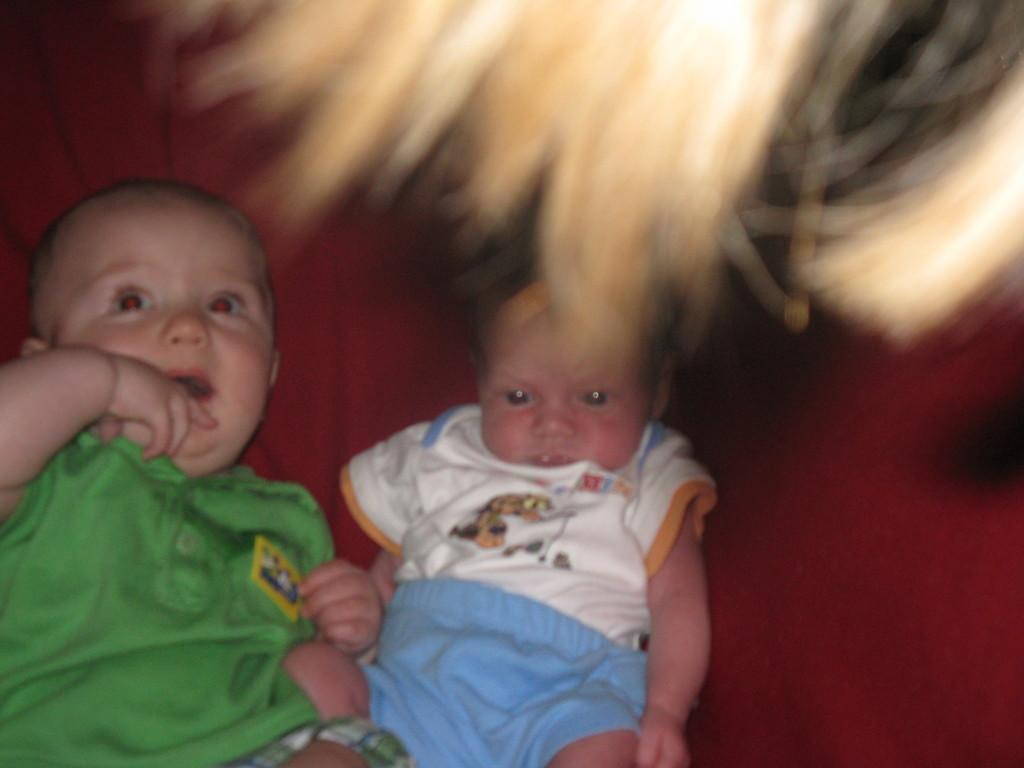How many children are in the image? There are two children in the image. What can be observed about the clothing of the child on the left? The child on the left is wearing green clothes. What type of jar is the child on the right holding in the image? There is no jar present in the image; both children are visible without any objects in their hands. 